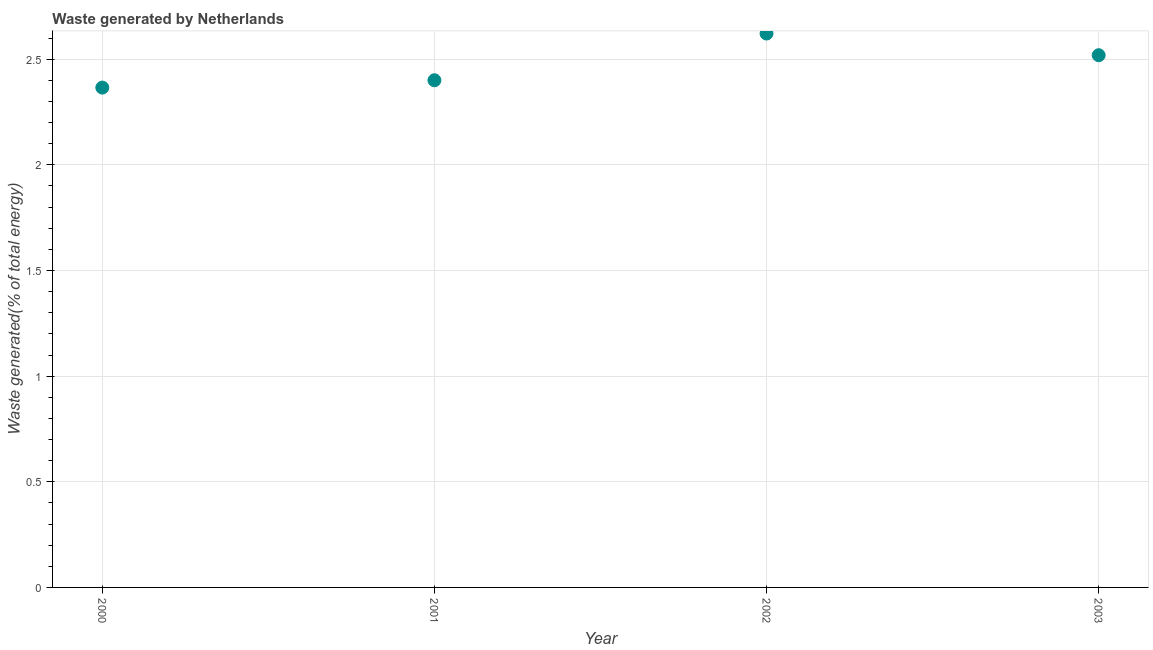What is the amount of waste generated in 2002?
Provide a succinct answer. 2.62. Across all years, what is the maximum amount of waste generated?
Your answer should be compact. 2.62. Across all years, what is the minimum amount of waste generated?
Offer a terse response. 2.37. In which year was the amount of waste generated minimum?
Your response must be concise. 2000. What is the sum of the amount of waste generated?
Provide a short and direct response. 9.91. What is the difference between the amount of waste generated in 2001 and 2002?
Offer a terse response. -0.22. What is the average amount of waste generated per year?
Provide a short and direct response. 2.48. What is the median amount of waste generated?
Give a very brief answer. 2.46. In how many years, is the amount of waste generated greater than 1.7 %?
Ensure brevity in your answer.  4. Do a majority of the years between 2003 and 2002 (inclusive) have amount of waste generated greater than 1.3 %?
Your response must be concise. No. What is the ratio of the amount of waste generated in 2000 to that in 2002?
Keep it short and to the point. 0.9. Is the amount of waste generated in 2002 less than that in 2003?
Make the answer very short. No. Is the difference between the amount of waste generated in 2000 and 2003 greater than the difference between any two years?
Your answer should be compact. No. What is the difference between the highest and the second highest amount of waste generated?
Your response must be concise. 0.1. Is the sum of the amount of waste generated in 2002 and 2003 greater than the maximum amount of waste generated across all years?
Give a very brief answer. Yes. What is the difference between the highest and the lowest amount of waste generated?
Provide a short and direct response. 0.26. How many dotlines are there?
Make the answer very short. 1. How many years are there in the graph?
Your answer should be compact. 4. Are the values on the major ticks of Y-axis written in scientific E-notation?
Your answer should be very brief. No. Does the graph contain any zero values?
Offer a terse response. No. What is the title of the graph?
Your answer should be compact. Waste generated by Netherlands. What is the label or title of the X-axis?
Offer a terse response. Year. What is the label or title of the Y-axis?
Your answer should be very brief. Waste generated(% of total energy). What is the Waste generated(% of total energy) in 2000?
Offer a terse response. 2.37. What is the Waste generated(% of total energy) in 2001?
Your answer should be compact. 2.4. What is the Waste generated(% of total energy) in 2002?
Your answer should be compact. 2.62. What is the Waste generated(% of total energy) in 2003?
Offer a very short reply. 2.52. What is the difference between the Waste generated(% of total energy) in 2000 and 2001?
Provide a succinct answer. -0.03. What is the difference between the Waste generated(% of total energy) in 2000 and 2002?
Provide a succinct answer. -0.26. What is the difference between the Waste generated(% of total energy) in 2000 and 2003?
Your answer should be compact. -0.15. What is the difference between the Waste generated(% of total energy) in 2001 and 2002?
Offer a terse response. -0.22. What is the difference between the Waste generated(% of total energy) in 2001 and 2003?
Offer a very short reply. -0.12. What is the difference between the Waste generated(% of total energy) in 2002 and 2003?
Your answer should be compact. 0.1. What is the ratio of the Waste generated(% of total energy) in 2000 to that in 2001?
Provide a short and direct response. 0.99. What is the ratio of the Waste generated(% of total energy) in 2000 to that in 2002?
Provide a succinct answer. 0.9. What is the ratio of the Waste generated(% of total energy) in 2000 to that in 2003?
Give a very brief answer. 0.94. What is the ratio of the Waste generated(% of total energy) in 2001 to that in 2002?
Your answer should be very brief. 0.92. What is the ratio of the Waste generated(% of total energy) in 2001 to that in 2003?
Give a very brief answer. 0.95. What is the ratio of the Waste generated(% of total energy) in 2002 to that in 2003?
Your response must be concise. 1.04. 